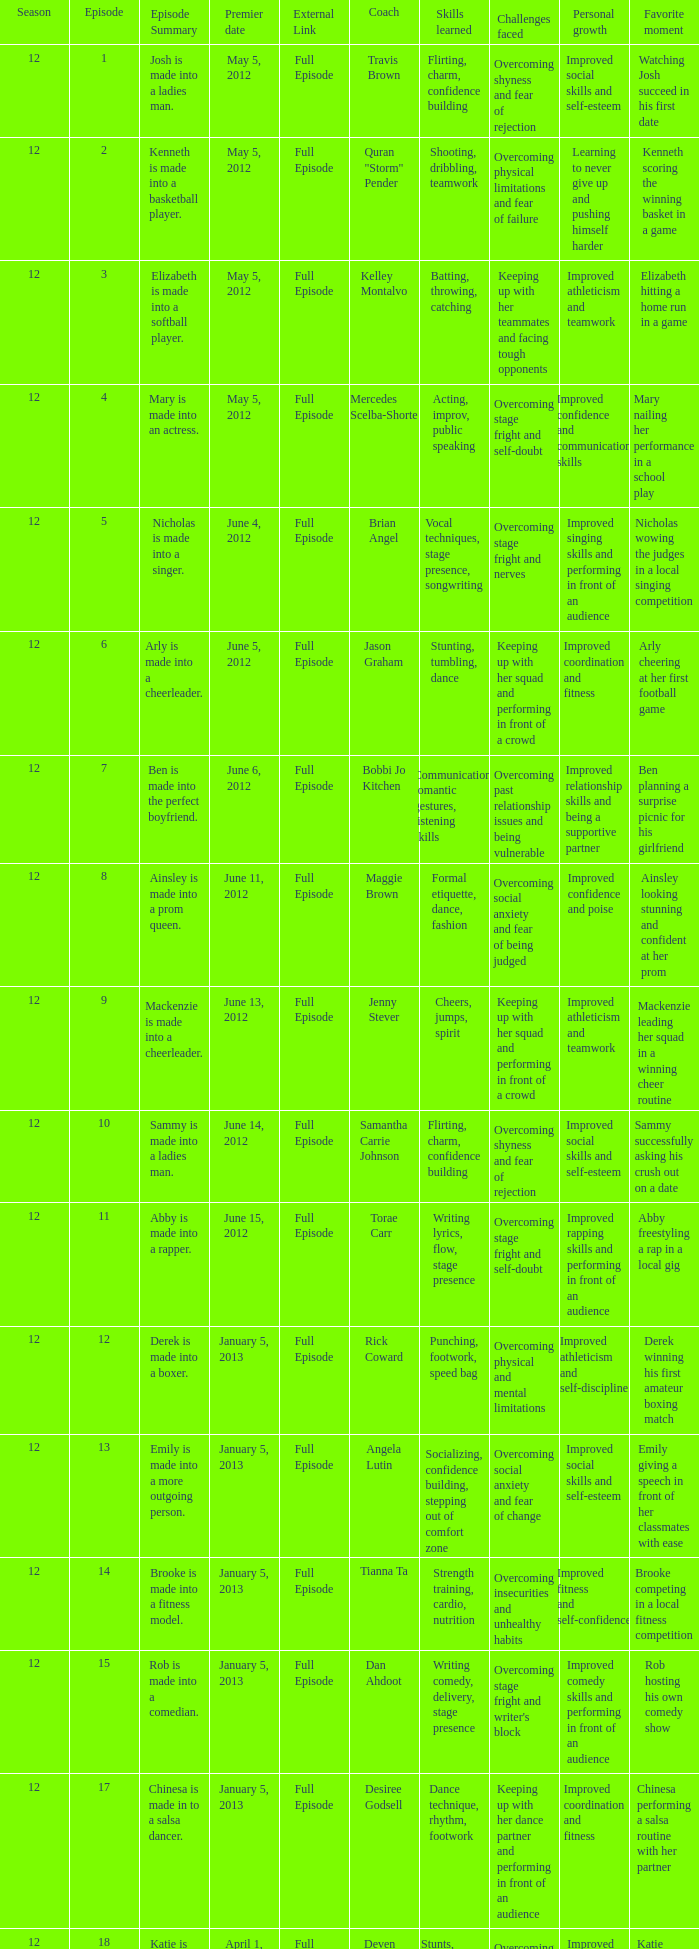Name the least episode for donnie klang 19.0. 